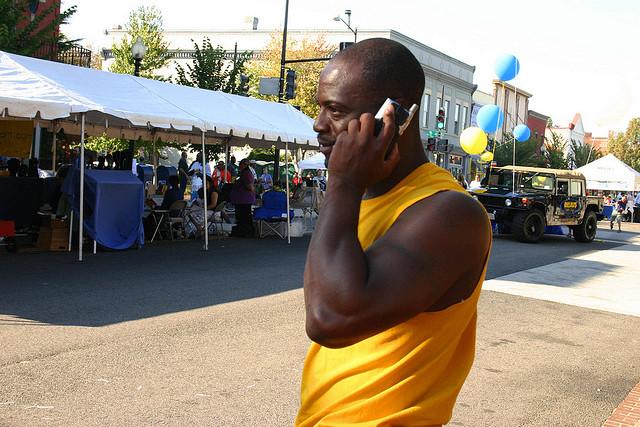How many balloons are in the photo?
Write a very short answer. 5. What kind of vehicle is in the background?
Short answer required. Jeep. What is the man holding?
Give a very brief answer. Cell phone. 